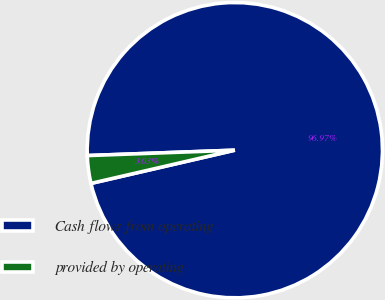Convert chart to OTSL. <chart><loc_0><loc_0><loc_500><loc_500><pie_chart><fcel>Cash flows from operating<fcel>provided by operating<nl><fcel>96.97%<fcel>3.03%<nl></chart> 